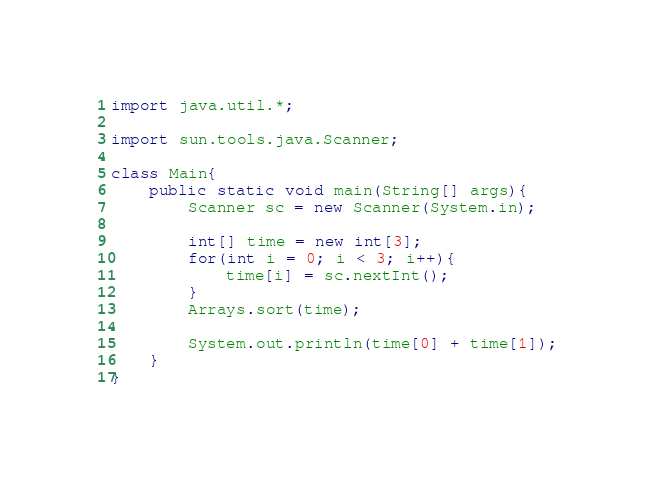Convert code to text. <code><loc_0><loc_0><loc_500><loc_500><_Java_>import java.util.*;

import sun.tools.java.Scanner;

class Main{
    public static void main(String[] args){
        Scanner sc = new Scanner(System.in);

        int[] time = new int[3];
        for(int i = 0; i < 3; i++){
            time[i] = sc.nextInt();
        }
        Arrays.sort(time);

        System.out.println(time[0] + time[1]);
    }
}</code> 